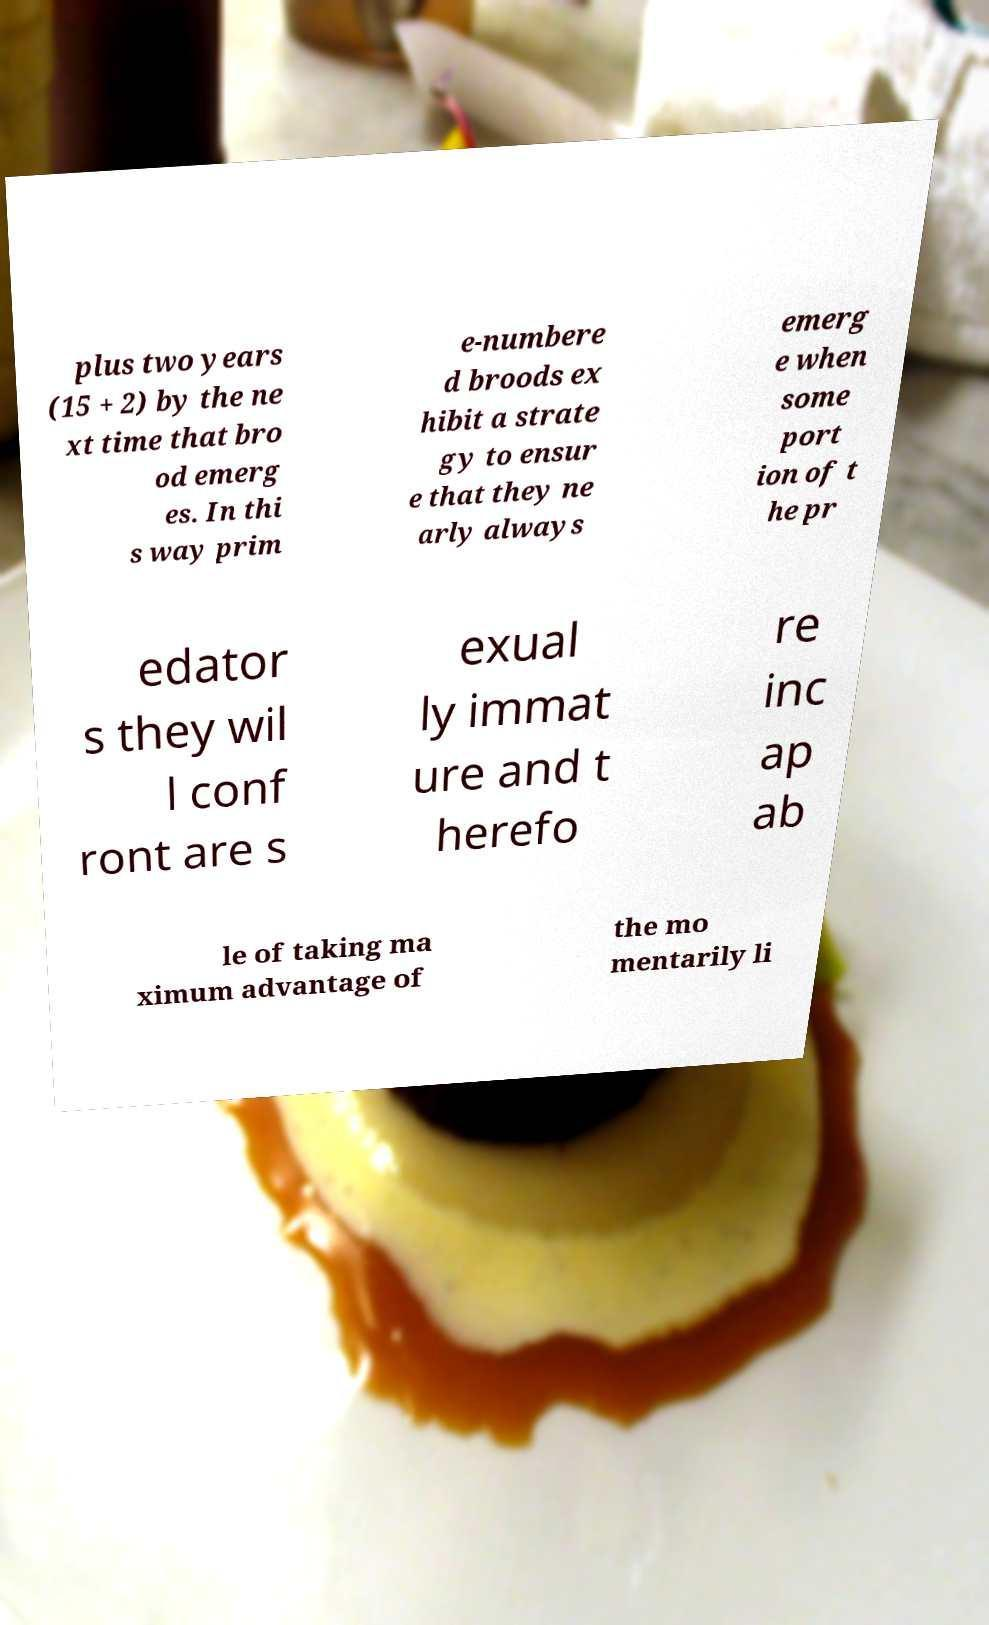There's text embedded in this image that I need extracted. Can you transcribe it verbatim? plus two years (15 + 2) by the ne xt time that bro od emerg es. In thi s way prim e-numbere d broods ex hibit a strate gy to ensur e that they ne arly always emerg e when some port ion of t he pr edator s they wil l conf ront are s exual ly immat ure and t herefo re inc ap ab le of taking ma ximum advantage of the mo mentarily li 